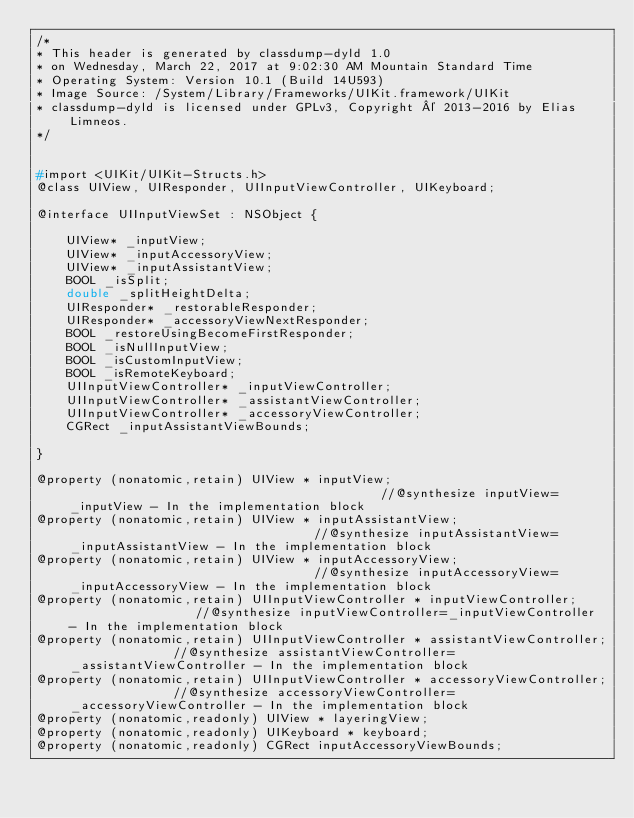Convert code to text. <code><loc_0><loc_0><loc_500><loc_500><_C_>/*
* This header is generated by classdump-dyld 1.0
* on Wednesday, March 22, 2017 at 9:02:30 AM Mountain Standard Time
* Operating System: Version 10.1 (Build 14U593)
* Image Source: /System/Library/Frameworks/UIKit.framework/UIKit
* classdump-dyld is licensed under GPLv3, Copyright © 2013-2016 by Elias Limneos.
*/


#import <UIKit/UIKit-Structs.h>
@class UIView, UIResponder, UIInputViewController, UIKeyboard;

@interface UIInputViewSet : NSObject {

	UIView* _inputView;
	UIView* _inputAccessoryView;
	UIView* _inputAssistantView;
	BOOL _isSplit;
	double _splitHeightDelta;
	UIResponder* _restorableResponder;
	UIResponder* _accessoryViewNextResponder;
	BOOL _restoreUsingBecomeFirstResponder;
	BOOL _isNullInputView;
	BOOL _isCustomInputView;
	BOOL _isRemoteKeyboard;
	UIInputViewController* _inputViewController;
	UIInputViewController* _assistantViewController;
	UIInputViewController* _accessoryViewController;
	CGRect _inputAssistantViewBounds;

}

@property (nonatomic,retain) UIView * inputView;                                           //@synthesize inputView=_inputView - In the implementation block
@property (nonatomic,retain) UIView * inputAssistantView;                                  //@synthesize inputAssistantView=_inputAssistantView - In the implementation block
@property (nonatomic,retain) UIView * inputAccessoryView;                                  //@synthesize inputAccessoryView=_inputAccessoryView - In the implementation block
@property (nonatomic,retain) UIInputViewController * inputViewController;                  //@synthesize inputViewController=_inputViewController - In the implementation block
@property (nonatomic,retain) UIInputViewController * assistantViewController;              //@synthesize assistantViewController=_assistantViewController - In the implementation block
@property (nonatomic,retain) UIInputViewController * accessoryViewController;              //@synthesize accessoryViewController=_accessoryViewController - In the implementation block
@property (nonatomic,readonly) UIView * layeringView; 
@property (nonatomic,readonly) UIKeyboard * keyboard; 
@property (nonatomic,readonly) CGRect inputAccessoryViewBounds; </code> 